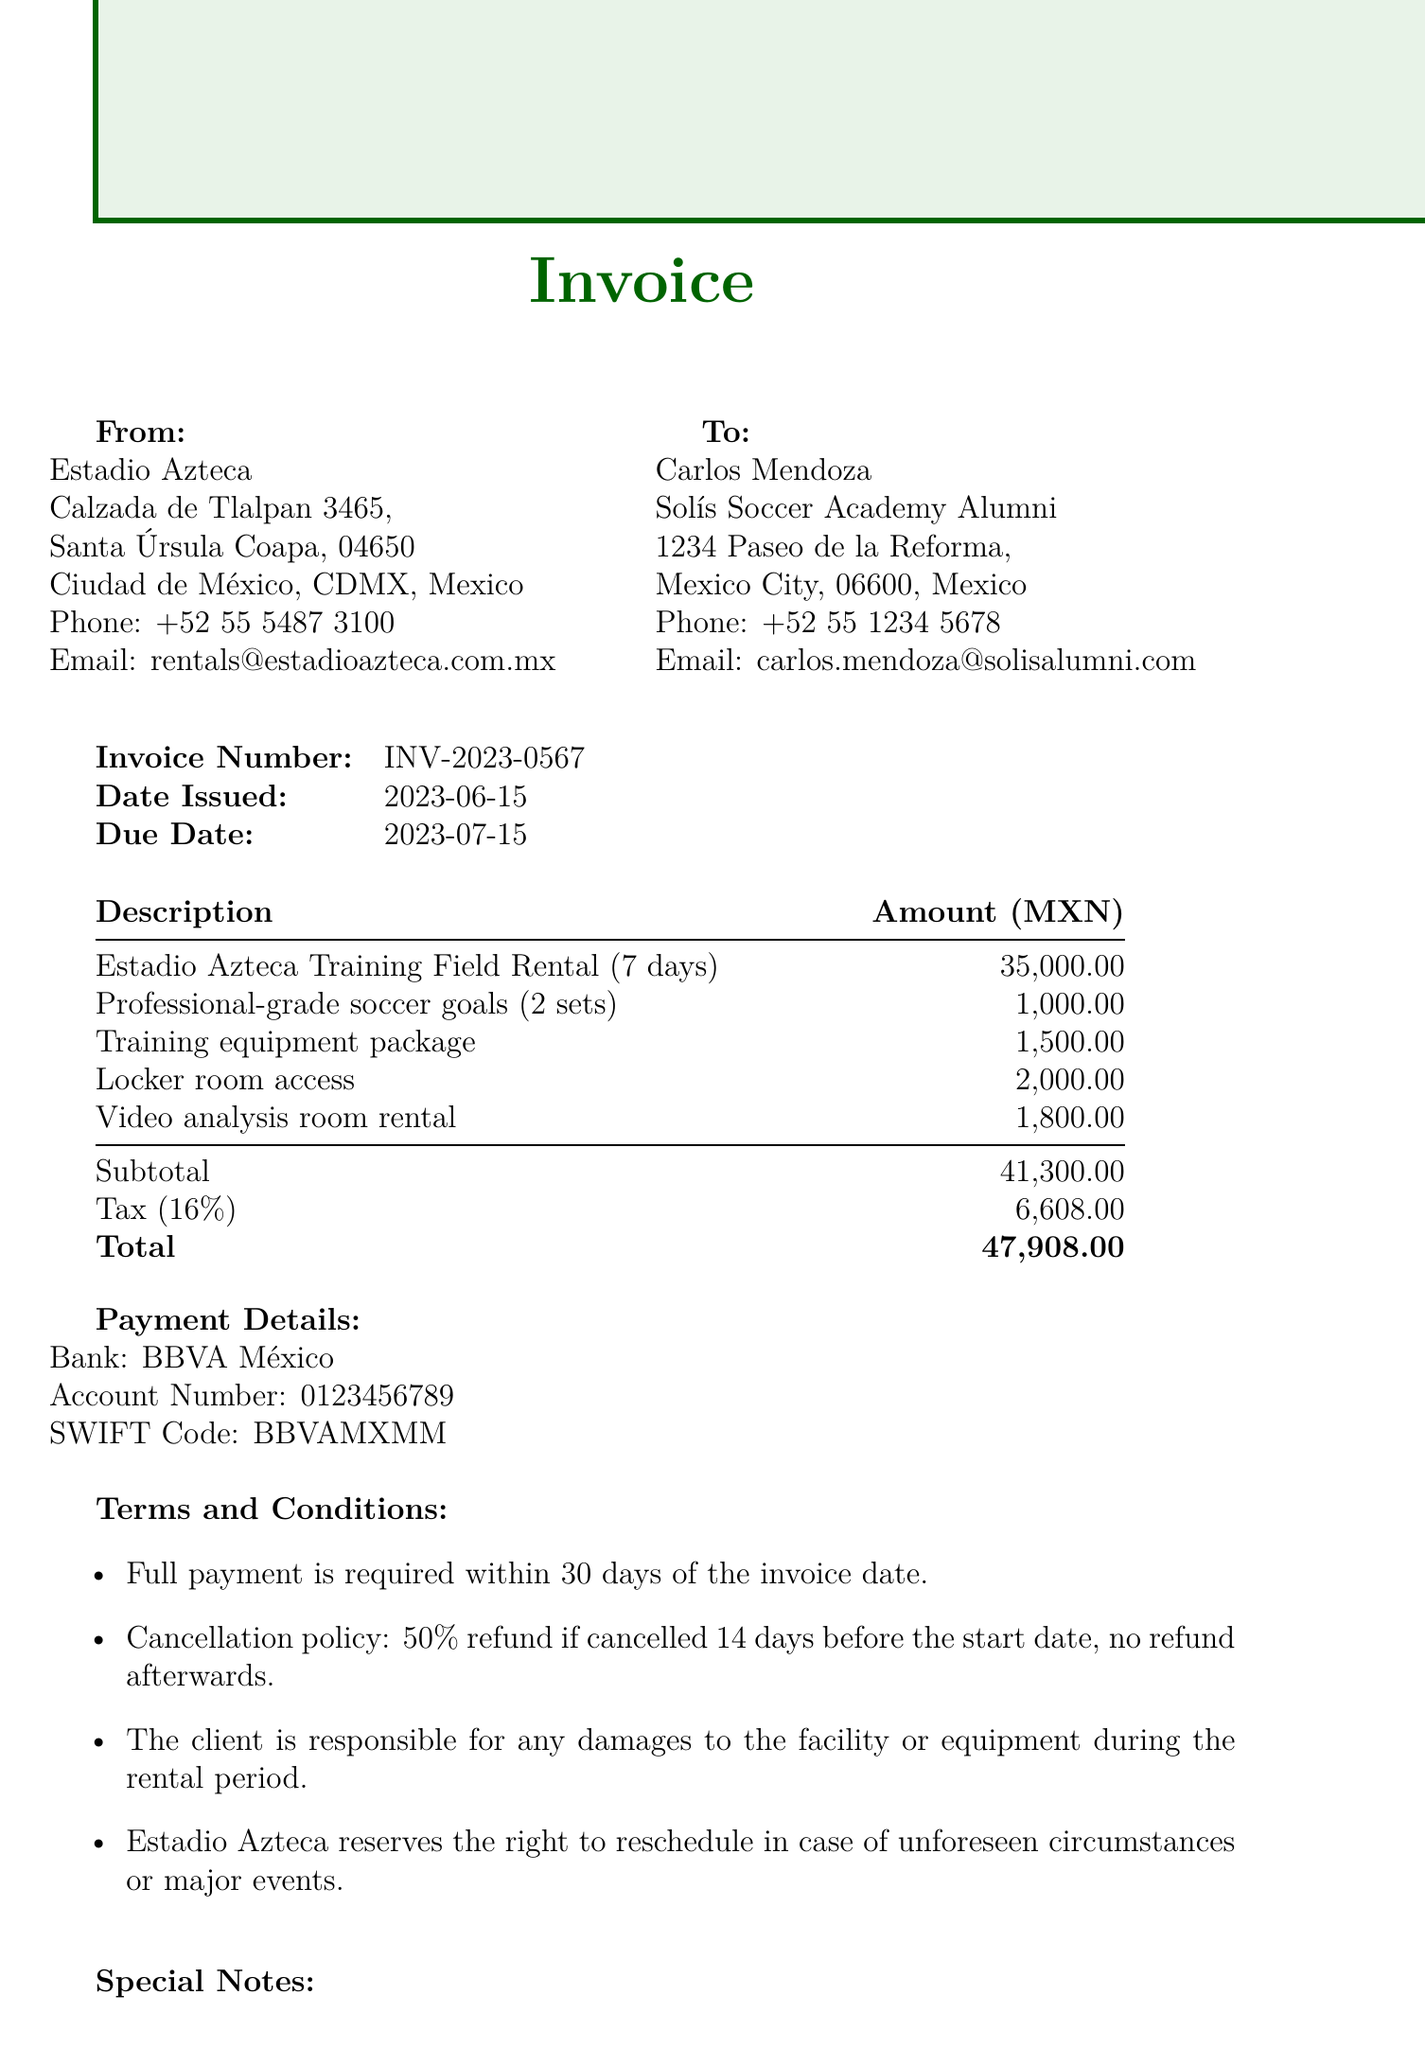What is the invoice number? The invoice number is clearly stated in the invoice details section.
Answer: INV-2023-0567 What is the total rental cost for the soccer field? The total rental cost is listed under rental details.
Answer: 35000 Who is the lead instructor for the clinic? The lead instructor's name is mentioned in the clinic details section.
Answer: Carlos Mendoza What is the due date for the invoice? The due date is specified in the invoice details section.
Answer: 2023-07-15 What discount has been applied to the total rental cost? The special notes mention a specific discount applied to the cost.
Answer: 10% What is the tax amount included in the invoice? The tax amount is calculated based on the subtotal and stated in the payment information.
Answer: 6608 How many expected participants are there for the clinic? The number of expected participants is found in the clinic details section.
Answer: 30 What payment method is specified in the payment information? The payment information section outlines the accepted method of payment.
Answer: Bank transfer What is the cancellation policy? The cancellation policy is detailed under terms and conditions, stating refund percentages.
Answer: 50% refund before 14 days 